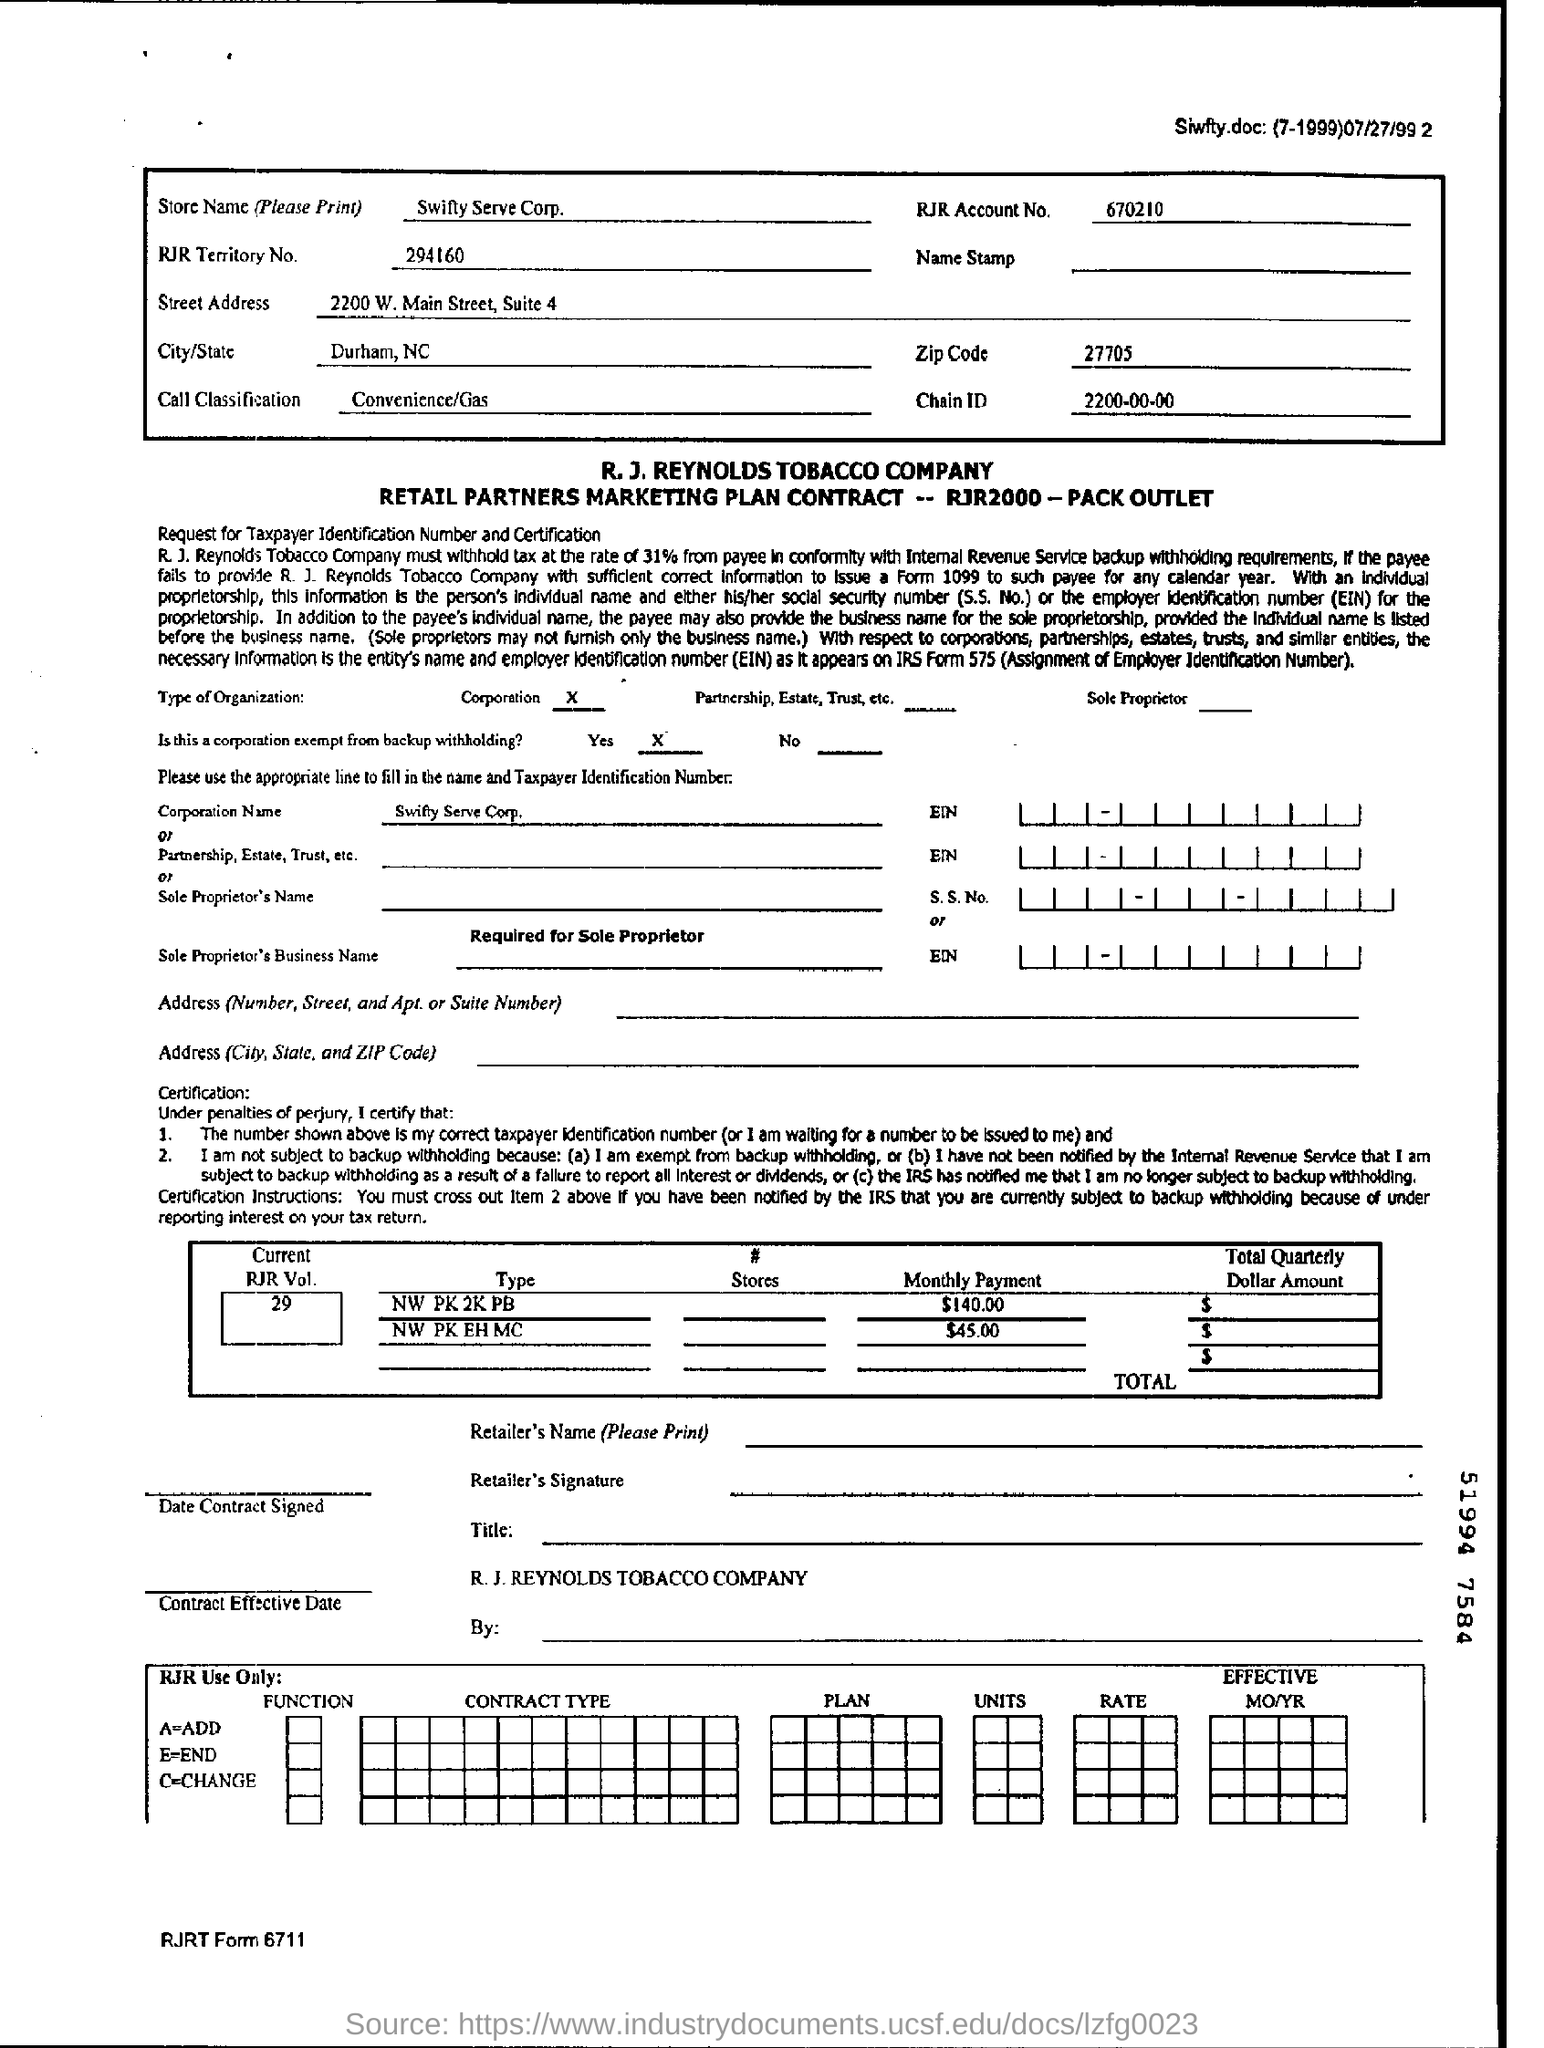What is the name of the Store?
Your response must be concise. Swifty Serve Corp. What is the RJR Account number?
Offer a very short reply. 670210. What is the chain ID?
Offer a terse response. 2200-00-00. 